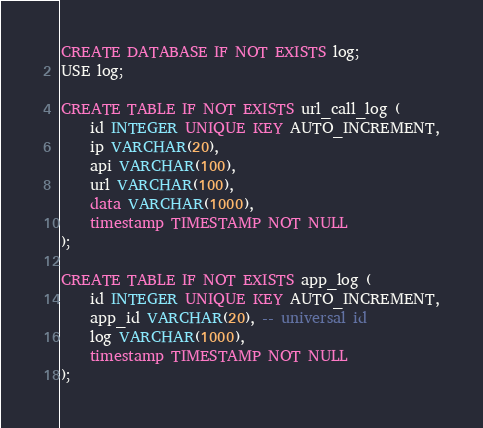<code> <loc_0><loc_0><loc_500><loc_500><_SQL_>CREATE DATABASE IF NOT EXISTS log;
USE log;

CREATE TABLE IF NOT EXISTS url_call_log (
	id INTEGER UNIQUE KEY AUTO_INCREMENT,
	ip VARCHAR(20),
	api VARCHAR(100),
	url VARCHAR(100),
	data VARCHAR(1000),
	timestamp TIMESTAMP NOT NULL
);

CREATE TABLE IF NOT EXISTS app_log (
	id INTEGER UNIQUE KEY AUTO_INCREMENT,
	app_id VARCHAR(20), -- universal id
	log VARCHAR(1000),
	timestamp TIMESTAMP NOT NULL
);</code> 